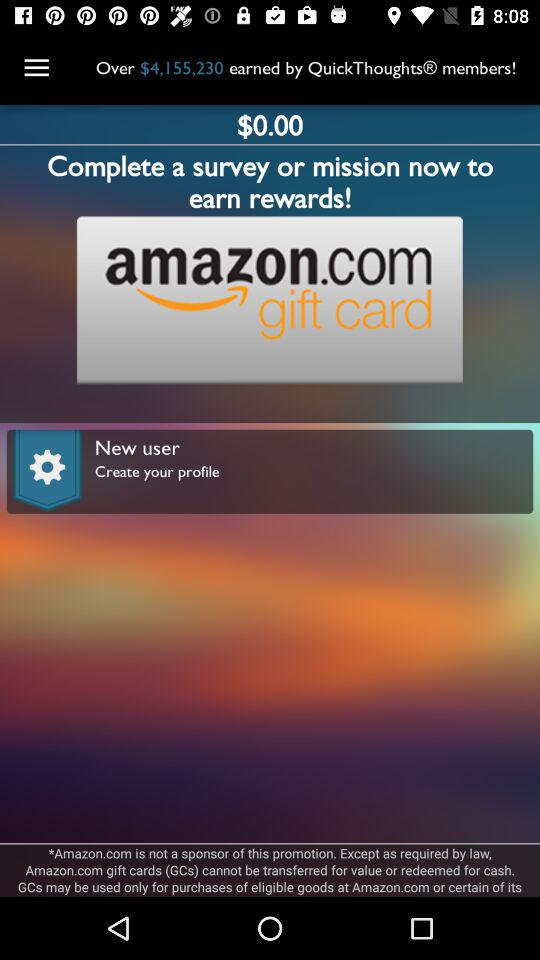How much more money has been earned by QuickThoughtsR members than the current balance?
Answer the question using a single word or phrase. $4,155,230 